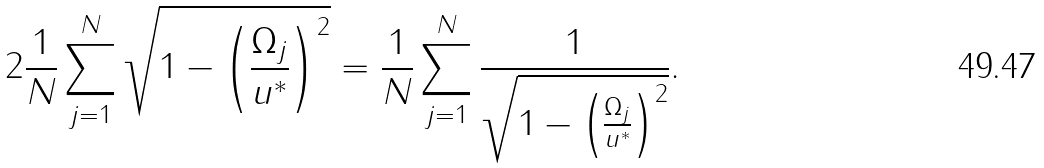<formula> <loc_0><loc_0><loc_500><loc_500>2 \frac { 1 } { N } \sum _ { j = 1 } ^ { N } \sqrt { 1 - \left ( \frac { \Omega _ { j } } { u ^ { * } } \right ) ^ { 2 } } = \frac { 1 } { N } \sum _ { j = 1 } ^ { N } \frac { 1 } { \sqrt { 1 - \left ( \frac { \Omega _ { j } } { u ^ { * } } \right ) ^ { 2 } } } .</formula> 